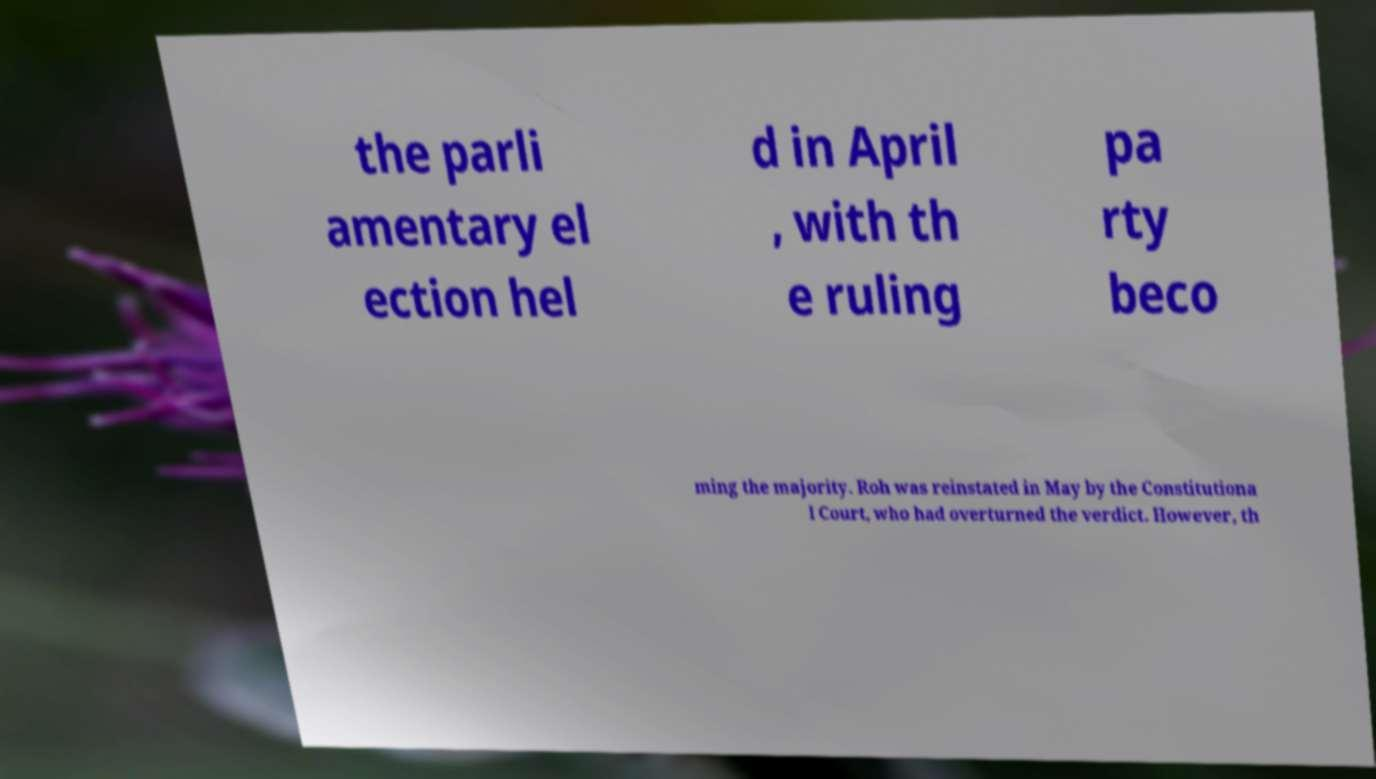What messages or text are displayed in this image? I need them in a readable, typed format. the parli amentary el ection hel d in April , with th e ruling pa rty beco ming the majority. Roh was reinstated in May by the Constitutiona l Court, who had overturned the verdict. However, th 